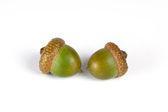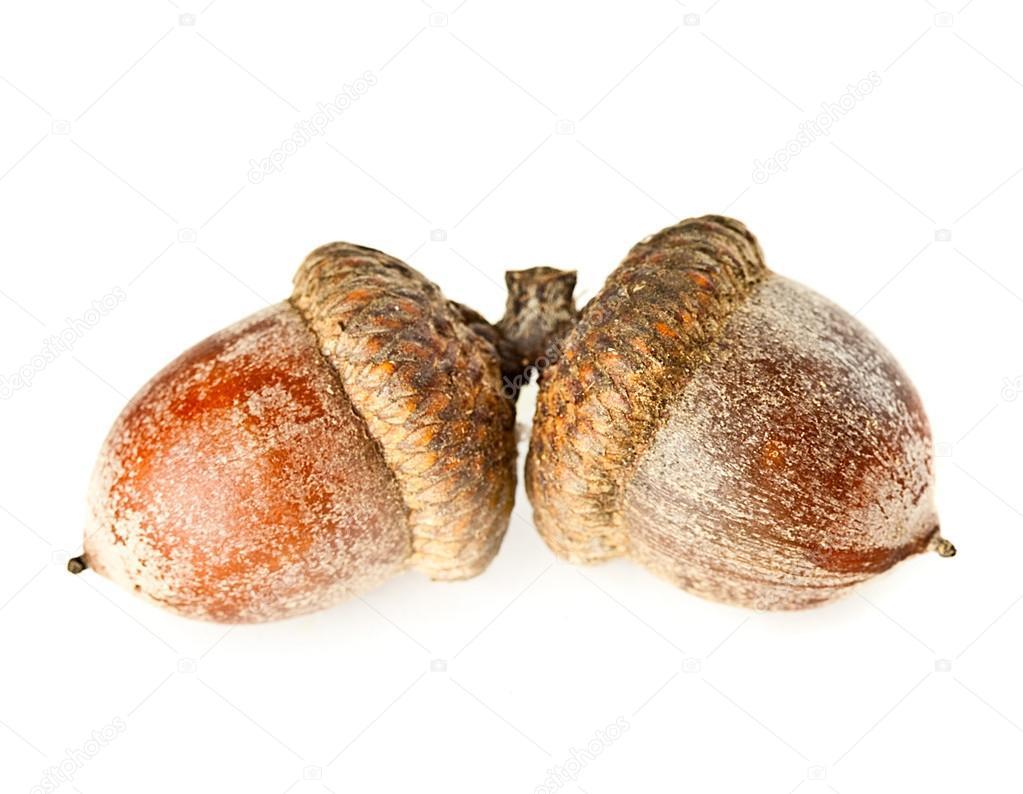The first image is the image on the left, the second image is the image on the right. For the images displayed, is the sentence "Each image contains one pair of acorns with their caps on, and no image contains a leaf." factually correct? Answer yes or no. Yes. The first image is the image on the left, the second image is the image on the right. Examine the images to the left and right. Is the description "There are four acorns with brown tops." accurate? Answer yes or no. Yes. 